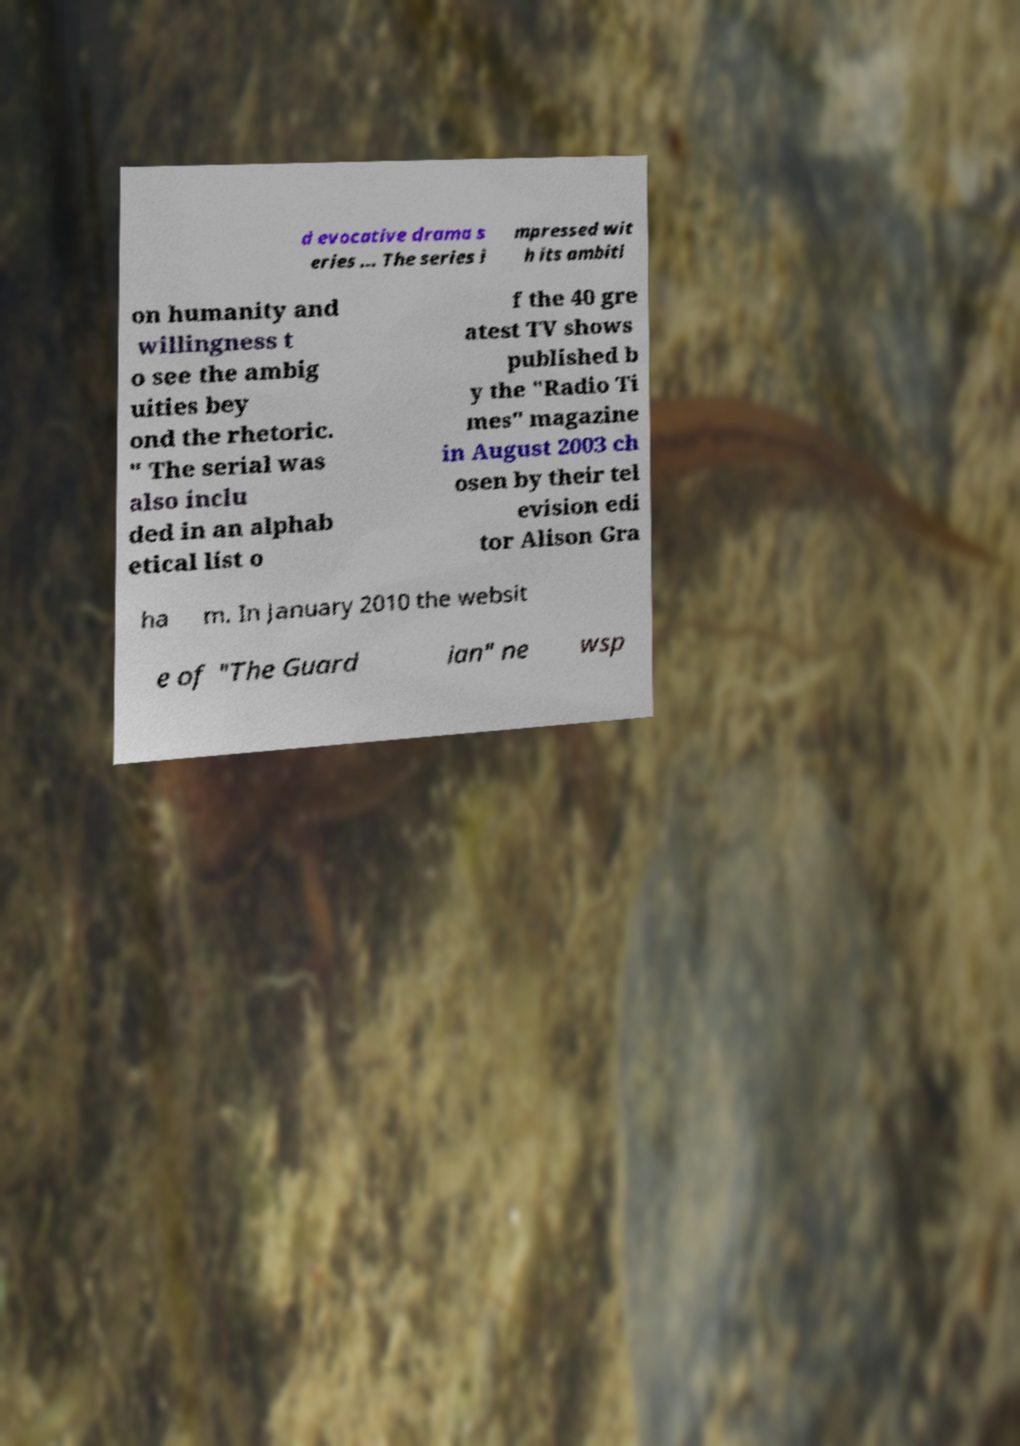What messages or text are displayed in this image? I need them in a readable, typed format. d evocative drama s eries ... The series i mpressed wit h its ambiti on humanity and willingness t o see the ambig uities bey ond the rhetoric. " The serial was also inclu ded in an alphab etical list o f the 40 gre atest TV shows published b y the "Radio Ti mes" magazine in August 2003 ch osen by their tel evision edi tor Alison Gra ha m. In January 2010 the websit e of "The Guard ian" ne wsp 